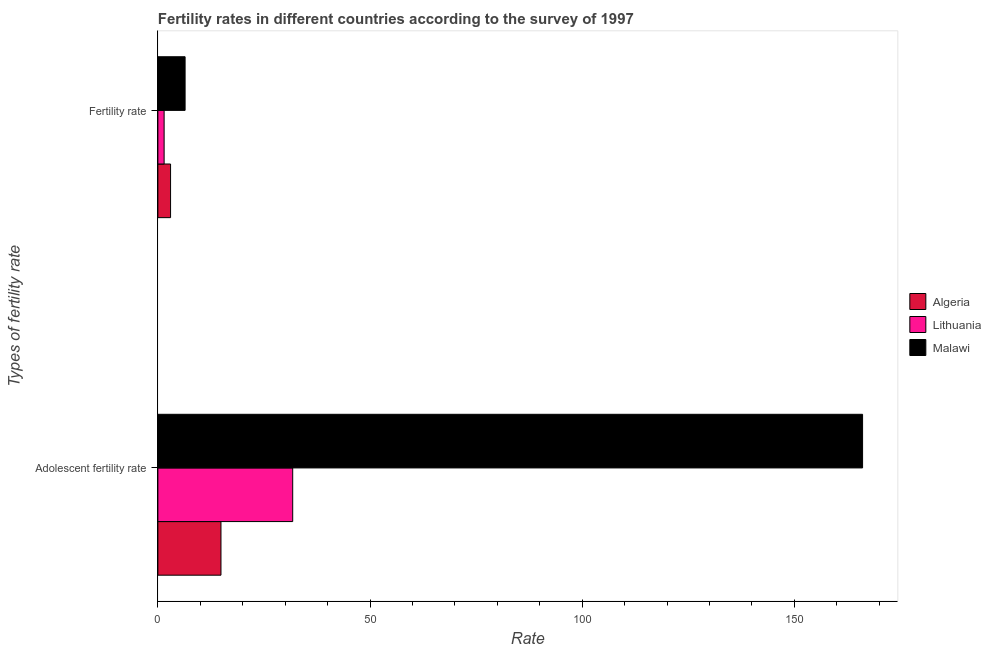How many different coloured bars are there?
Ensure brevity in your answer.  3. How many groups of bars are there?
Your answer should be compact. 2. Are the number of bars per tick equal to the number of legend labels?
Your answer should be compact. Yes. Are the number of bars on each tick of the Y-axis equal?
Provide a succinct answer. Yes. What is the label of the 1st group of bars from the top?
Offer a very short reply. Fertility rate. What is the adolescent fertility rate in Lithuania?
Keep it short and to the point. 31.77. Across all countries, what is the maximum fertility rate?
Offer a terse response. 6.41. Across all countries, what is the minimum fertility rate?
Offer a very short reply. 1.47. In which country was the fertility rate maximum?
Provide a short and direct response. Malawi. In which country was the adolescent fertility rate minimum?
Provide a short and direct response. Algeria. What is the total fertility rate in the graph?
Your answer should be compact. 10.87. What is the difference between the fertility rate in Lithuania and that in Algeria?
Your answer should be compact. -1.52. What is the difference between the fertility rate in Algeria and the adolescent fertility rate in Lithuania?
Ensure brevity in your answer.  -28.79. What is the average fertility rate per country?
Provide a succinct answer. 3.62. What is the difference between the fertility rate and adolescent fertility rate in Lithuania?
Your response must be concise. -30.3. In how many countries, is the adolescent fertility rate greater than 90 ?
Offer a terse response. 1. What is the ratio of the adolescent fertility rate in Algeria to that in Lithuania?
Offer a very short reply. 0.47. What does the 2nd bar from the top in Fertility rate represents?
Ensure brevity in your answer.  Lithuania. What does the 1st bar from the bottom in Fertility rate represents?
Make the answer very short. Algeria. How many bars are there?
Offer a terse response. 6. How many countries are there in the graph?
Provide a succinct answer. 3. What is the difference between two consecutive major ticks on the X-axis?
Offer a terse response. 50. Does the graph contain any zero values?
Your answer should be compact. No. Does the graph contain grids?
Make the answer very short. No. Where does the legend appear in the graph?
Your answer should be compact. Center right. How many legend labels are there?
Offer a very short reply. 3. How are the legend labels stacked?
Ensure brevity in your answer.  Vertical. What is the title of the graph?
Your answer should be compact. Fertility rates in different countries according to the survey of 1997. What is the label or title of the X-axis?
Ensure brevity in your answer.  Rate. What is the label or title of the Y-axis?
Give a very brief answer. Types of fertility rate. What is the Rate of Algeria in Adolescent fertility rate?
Your answer should be compact. 14.87. What is the Rate in Lithuania in Adolescent fertility rate?
Ensure brevity in your answer.  31.77. What is the Rate in Malawi in Adolescent fertility rate?
Offer a terse response. 166.09. What is the Rate of Algeria in Fertility rate?
Offer a very short reply. 2.99. What is the Rate in Lithuania in Fertility rate?
Offer a terse response. 1.47. What is the Rate in Malawi in Fertility rate?
Offer a very short reply. 6.41. Across all Types of fertility rate, what is the maximum Rate of Algeria?
Keep it short and to the point. 14.87. Across all Types of fertility rate, what is the maximum Rate of Lithuania?
Keep it short and to the point. 31.77. Across all Types of fertility rate, what is the maximum Rate in Malawi?
Provide a short and direct response. 166.09. Across all Types of fertility rate, what is the minimum Rate in Algeria?
Give a very brief answer. 2.99. Across all Types of fertility rate, what is the minimum Rate of Lithuania?
Make the answer very short. 1.47. Across all Types of fertility rate, what is the minimum Rate in Malawi?
Provide a succinct answer. 6.41. What is the total Rate in Algeria in the graph?
Your response must be concise. 17.86. What is the total Rate in Lithuania in the graph?
Ensure brevity in your answer.  33.24. What is the total Rate of Malawi in the graph?
Your response must be concise. 172.51. What is the difference between the Rate of Algeria in Adolescent fertility rate and that in Fertility rate?
Give a very brief answer. 11.88. What is the difference between the Rate in Lithuania in Adolescent fertility rate and that in Fertility rate?
Provide a succinct answer. 30.3. What is the difference between the Rate in Malawi in Adolescent fertility rate and that in Fertility rate?
Offer a terse response. 159.68. What is the difference between the Rate of Algeria in Adolescent fertility rate and the Rate of Lithuania in Fertility rate?
Make the answer very short. 13.4. What is the difference between the Rate of Algeria in Adolescent fertility rate and the Rate of Malawi in Fertility rate?
Make the answer very short. 8.46. What is the difference between the Rate of Lithuania in Adolescent fertility rate and the Rate of Malawi in Fertility rate?
Give a very brief answer. 25.36. What is the average Rate of Algeria per Types of fertility rate?
Give a very brief answer. 8.93. What is the average Rate in Lithuania per Types of fertility rate?
Your response must be concise. 16.62. What is the average Rate of Malawi per Types of fertility rate?
Ensure brevity in your answer.  86.25. What is the difference between the Rate of Algeria and Rate of Lithuania in Adolescent fertility rate?
Your response must be concise. -16.91. What is the difference between the Rate in Algeria and Rate in Malawi in Adolescent fertility rate?
Offer a very short reply. -151.22. What is the difference between the Rate in Lithuania and Rate in Malawi in Adolescent fertility rate?
Provide a succinct answer. -134.32. What is the difference between the Rate in Algeria and Rate in Lithuania in Fertility rate?
Provide a short and direct response. 1.52. What is the difference between the Rate of Algeria and Rate of Malawi in Fertility rate?
Provide a succinct answer. -3.43. What is the difference between the Rate of Lithuania and Rate of Malawi in Fertility rate?
Your answer should be compact. -4.94. What is the ratio of the Rate of Algeria in Adolescent fertility rate to that in Fertility rate?
Make the answer very short. 4.98. What is the ratio of the Rate in Lithuania in Adolescent fertility rate to that in Fertility rate?
Your answer should be very brief. 21.61. What is the ratio of the Rate of Malawi in Adolescent fertility rate to that in Fertility rate?
Your response must be concise. 25.9. What is the difference between the highest and the second highest Rate in Algeria?
Provide a short and direct response. 11.88. What is the difference between the highest and the second highest Rate in Lithuania?
Make the answer very short. 30.3. What is the difference between the highest and the second highest Rate of Malawi?
Offer a very short reply. 159.68. What is the difference between the highest and the lowest Rate in Algeria?
Keep it short and to the point. 11.88. What is the difference between the highest and the lowest Rate in Lithuania?
Your answer should be compact. 30.3. What is the difference between the highest and the lowest Rate in Malawi?
Your answer should be compact. 159.68. 